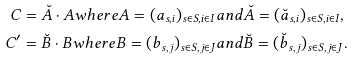Convert formula to latex. <formula><loc_0><loc_0><loc_500><loc_500>C & = \breve { A } \cdot A w h e r e A = ( a _ { s , i } ) _ { s \in S , i \in I } a n d \breve { A } = ( \breve { a } _ { s , i } ) _ { s \in S , i \in I } , \\ C ^ { \prime } & = \breve { B } \cdot B w h e r e B = ( b _ { s , j } ) _ { s \in S , j \in J } a n d \breve { B } = ( \breve { b } _ { s , j } ) _ { s \in S , j \in J } .</formula> 